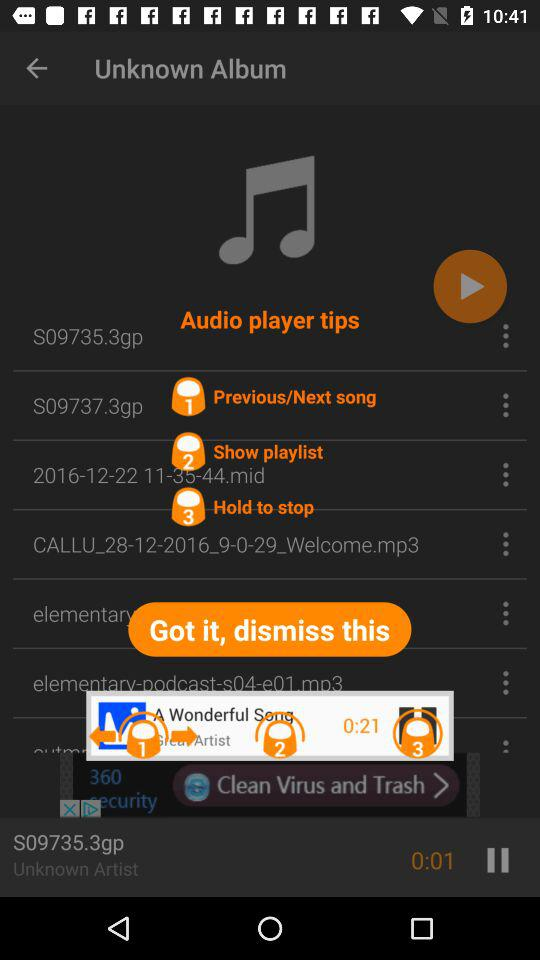What is the 2nd tip of the audio player? The 2nd tip is "Show playlist". 